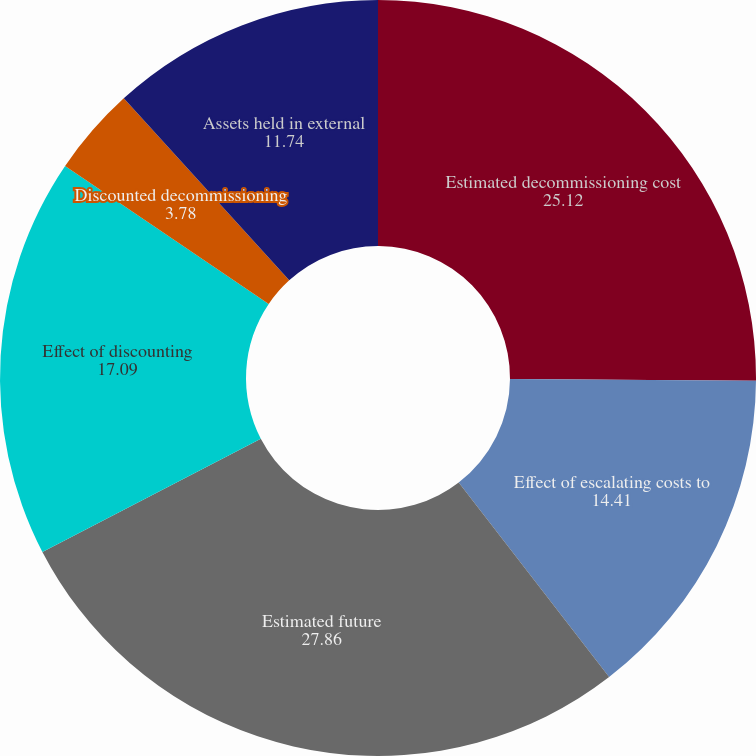Convert chart to OTSL. <chart><loc_0><loc_0><loc_500><loc_500><pie_chart><fcel>Estimated decommissioning cost<fcel>Effect of escalating costs to<fcel>Estimated future<fcel>Effect of discounting<fcel>Discounted decommissioning<fcel>Assets held in external<nl><fcel>25.12%<fcel>14.41%<fcel>27.86%<fcel>17.09%<fcel>3.78%<fcel>11.74%<nl></chart> 